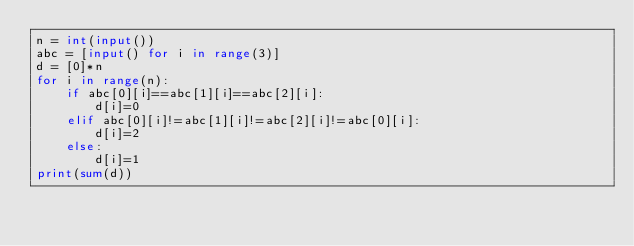<code> <loc_0><loc_0><loc_500><loc_500><_Python_>n = int(input())
abc = [input() for i in range(3)]
d = [0]*n
for i in range(n):
    if abc[0][i]==abc[1][i]==abc[2][i]:
        d[i]=0
    elif abc[0][i]!=abc[1][i]!=abc[2][i]!=abc[0][i]:
        d[i]=2
    else:
        d[i]=1
print(sum(d))</code> 